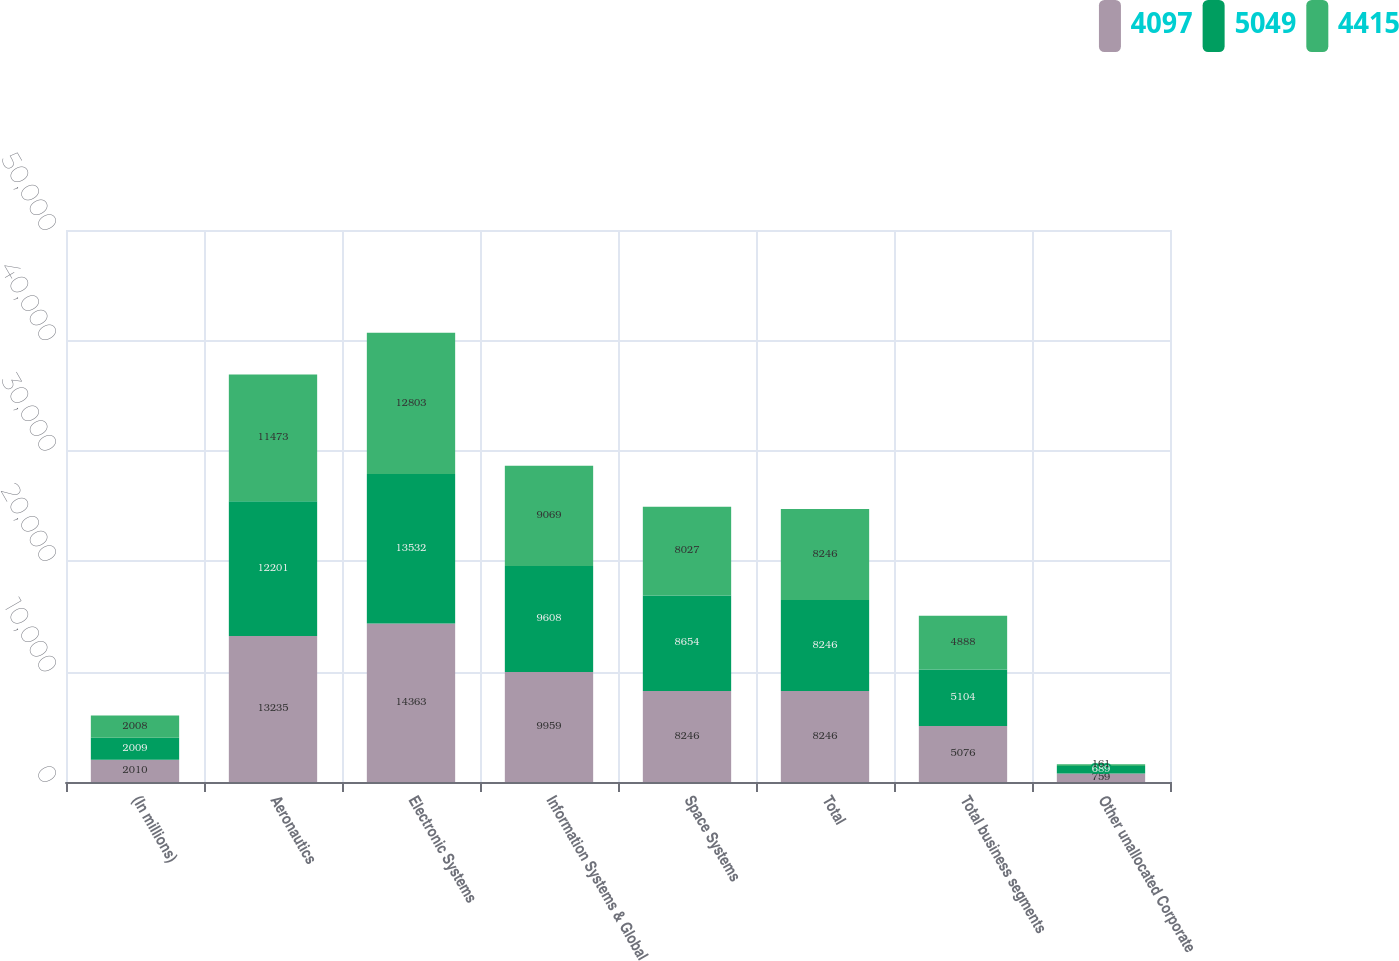Convert chart to OTSL. <chart><loc_0><loc_0><loc_500><loc_500><stacked_bar_chart><ecel><fcel>(In millions)<fcel>Aeronautics<fcel>Electronic Systems<fcel>Information Systems & Global<fcel>Space Systems<fcel>Total<fcel>Total business segments<fcel>Other unallocated Corporate<nl><fcel>4097<fcel>2010<fcel>13235<fcel>14363<fcel>9959<fcel>8246<fcel>8246<fcel>5076<fcel>759<nl><fcel>5049<fcel>2009<fcel>12201<fcel>13532<fcel>9608<fcel>8654<fcel>8246<fcel>5104<fcel>689<nl><fcel>4415<fcel>2008<fcel>11473<fcel>12803<fcel>9069<fcel>8027<fcel>8246<fcel>4888<fcel>161<nl></chart> 